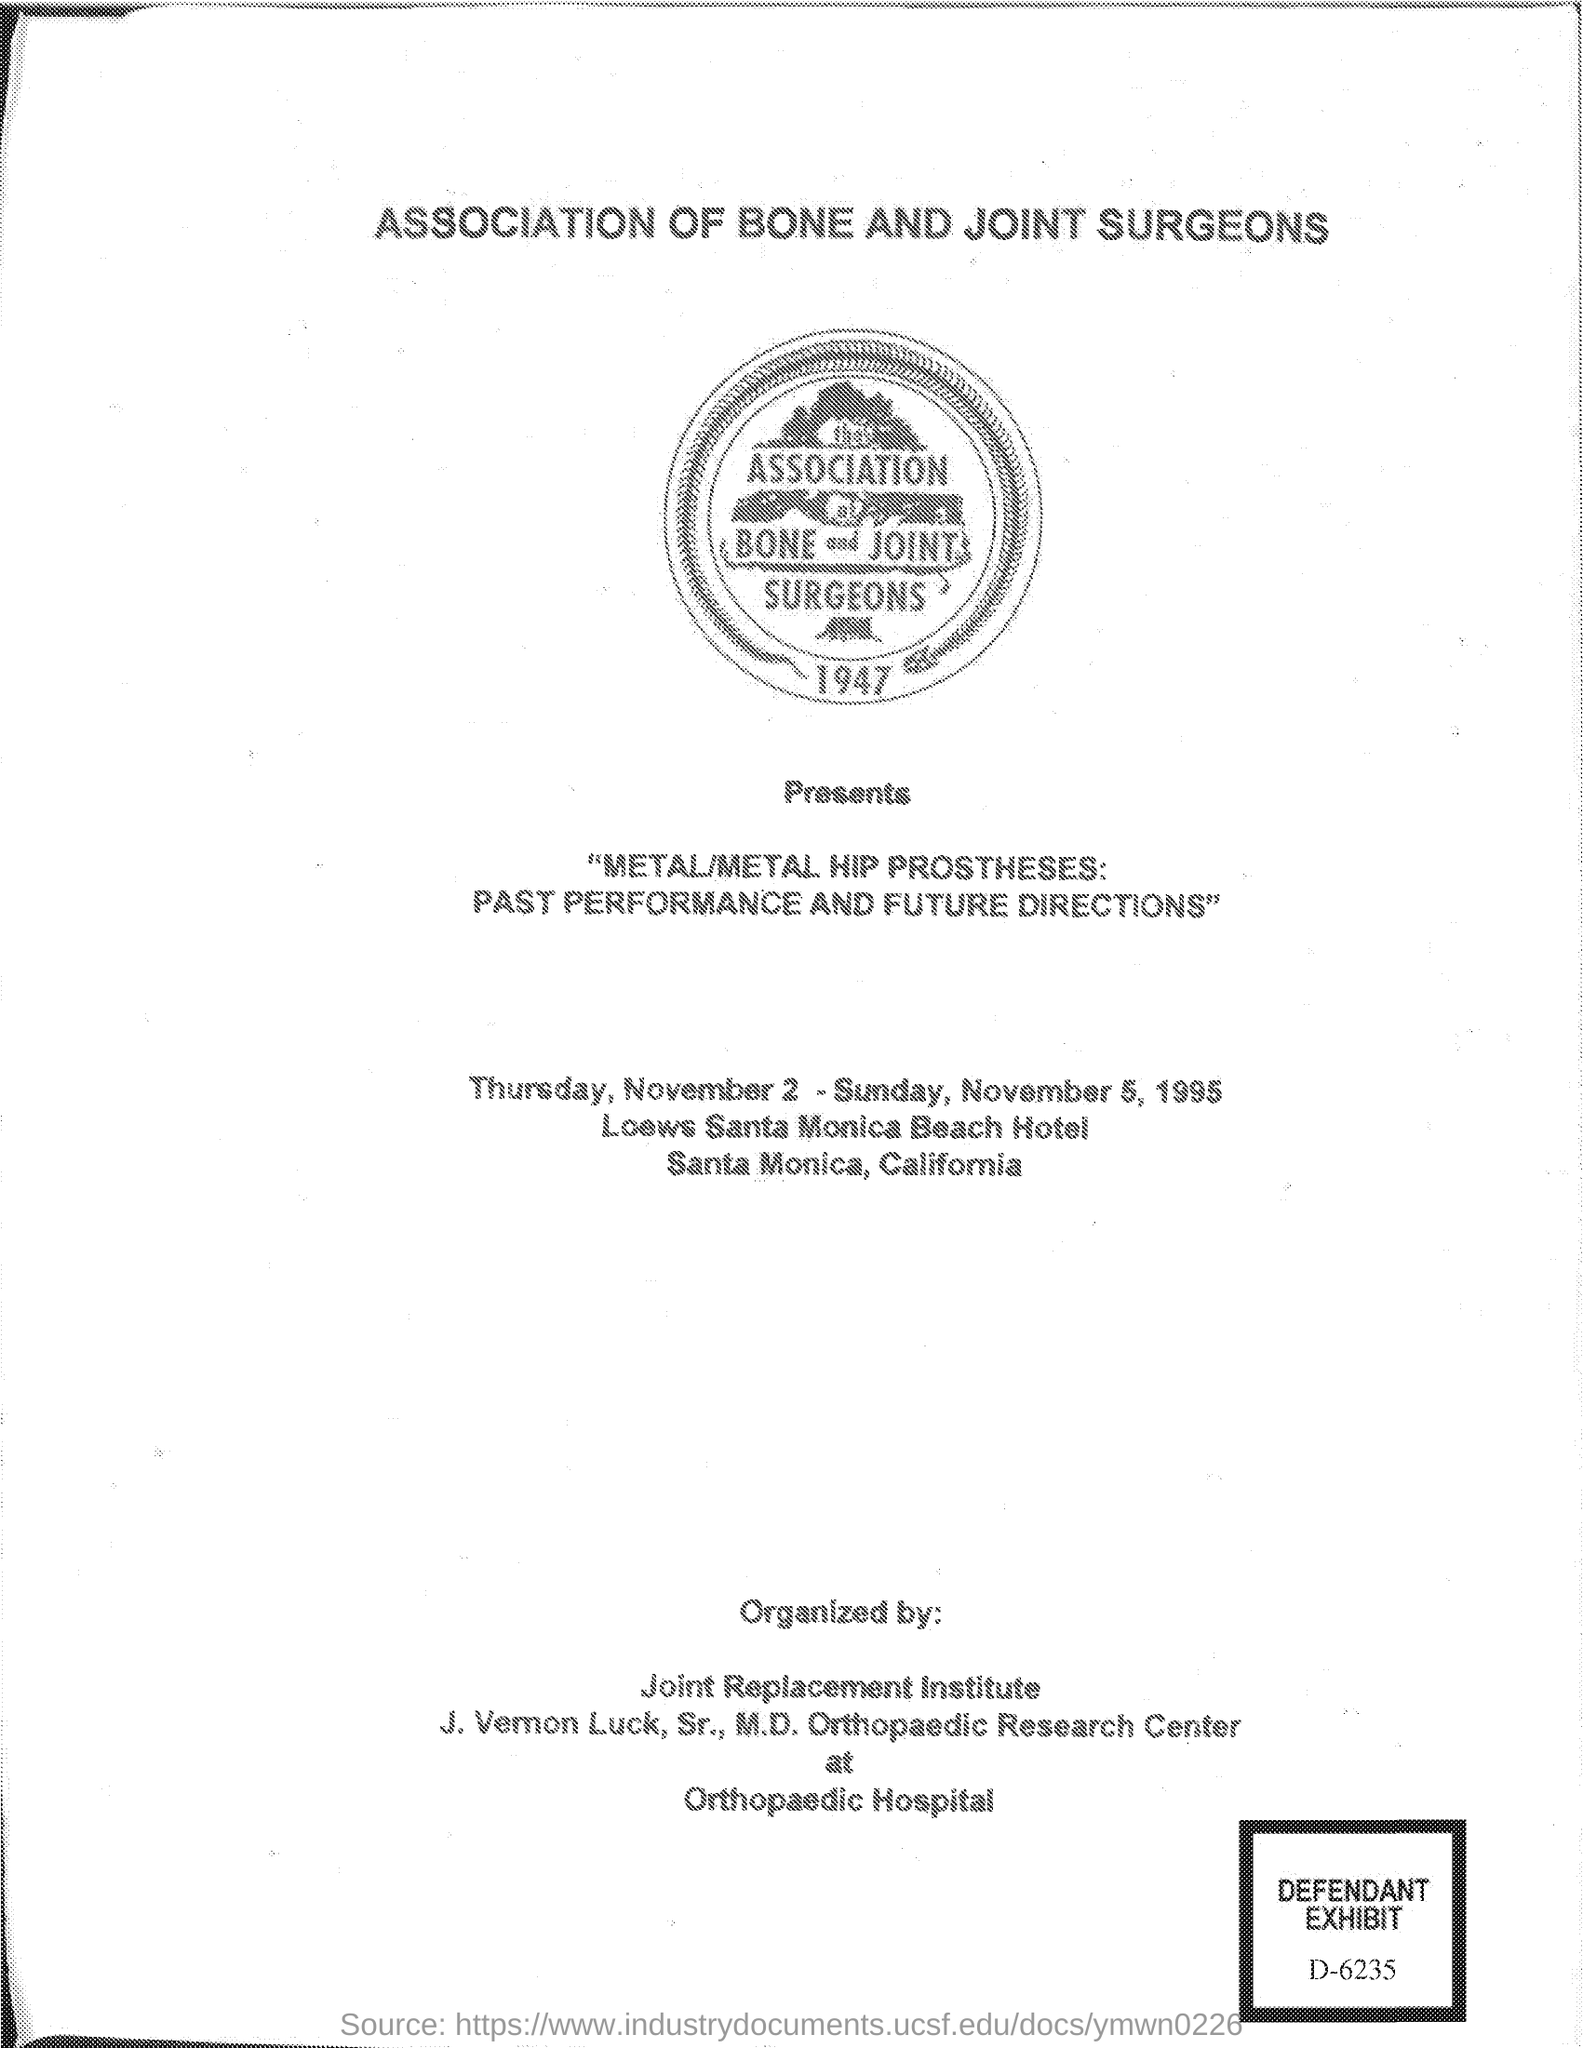When is the association held?
Ensure brevity in your answer.  Thursday, November 2- Sunday, November 5, 1995. Where is the association held?
Keep it short and to the point. LOEWS SANTA MONICA BEACH HOTEL. 